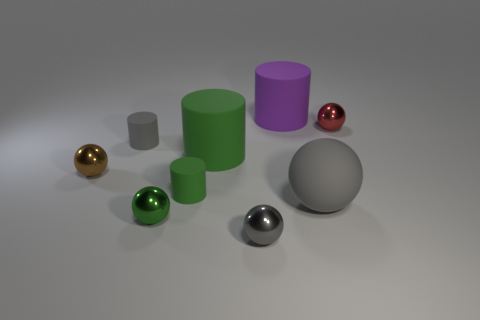What color is the other big matte thing that is the same shape as the purple thing?
Provide a short and direct response. Green. How many green rubber things have the same shape as the big purple thing?
Ensure brevity in your answer.  2. How many objects are gray metal spheres or gray things that are in front of the tiny green cylinder?
Make the answer very short. 2. There is a matte sphere; is it the same color as the small cylinder behind the brown sphere?
Offer a terse response. Yes. There is a gray thing that is to the left of the large gray matte sphere and in front of the small gray rubber thing; how big is it?
Your answer should be very brief. Small. There is a green metallic thing; are there any green objects right of it?
Your answer should be very brief. Yes. There is a gray object that is in front of the green shiny object; is there a tiny red metallic ball left of it?
Provide a succinct answer. No. Is the number of green matte cylinders behind the gray rubber cylinder the same as the number of metallic things left of the small red metallic ball?
Keep it short and to the point. No. What color is the ball that is made of the same material as the purple cylinder?
Make the answer very short. Gray. Are there any small brown spheres that have the same material as the tiny gray ball?
Your answer should be compact. Yes. 